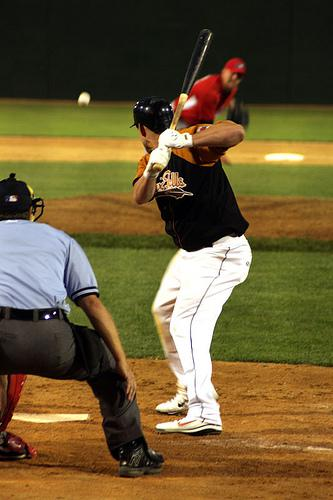Question: where is this picture taken?
Choices:
A. Outside.
B. At a park.
C. Soccer field.
D. In the baseball field.
Answer with the letter. Answer: D Question: why is the man holding a bat?
Choices:
A. He's taking it back to the dugout.
B. To hit a burglar.
C. Playing baseball.
D. To hit the ball.
Answer with the letter. Answer: D Question: when is this picture taken?
Choices:
A. Night.
B. Morning.
C. Noon.
D. Evening.
Answer with the letter. Answer: D Question: who is in the picture?
Choices:
A. Children.
B. Three men.
C. Woman.
D. A family.
Answer with the letter. Answer: B Question: how is the man in black posed?
Choices:
A. Standing.
B. He is crouching.
C. Sitting.
D. Squatting.
Answer with the letter. Answer: B 